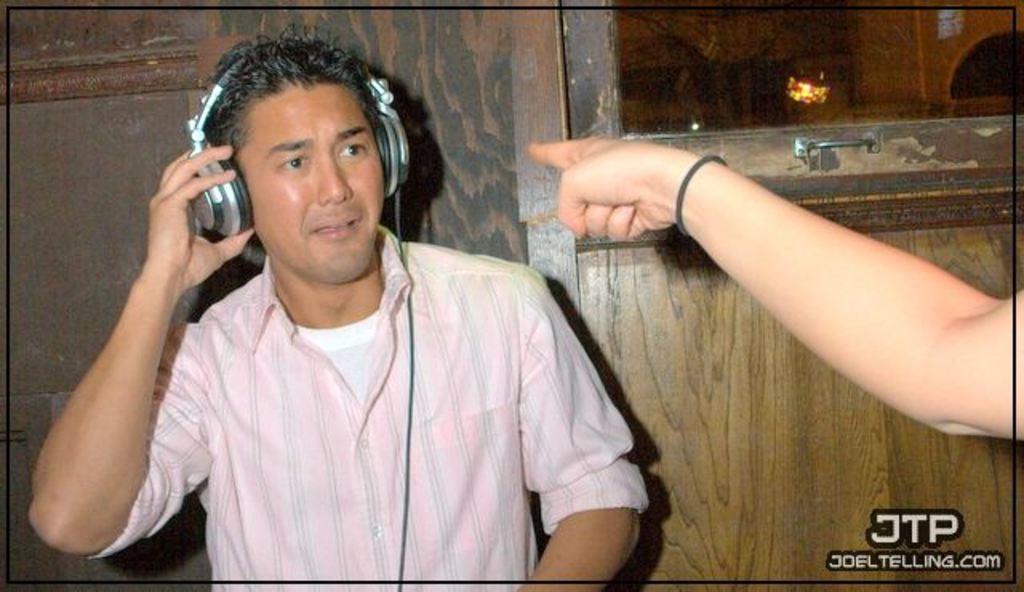In one or two sentences, can you explain what this image depicts? In this image we can see a person wearing headphone. On the right side of the image we can see a hand of a person. In the background, we can see a door, light and the wall. 